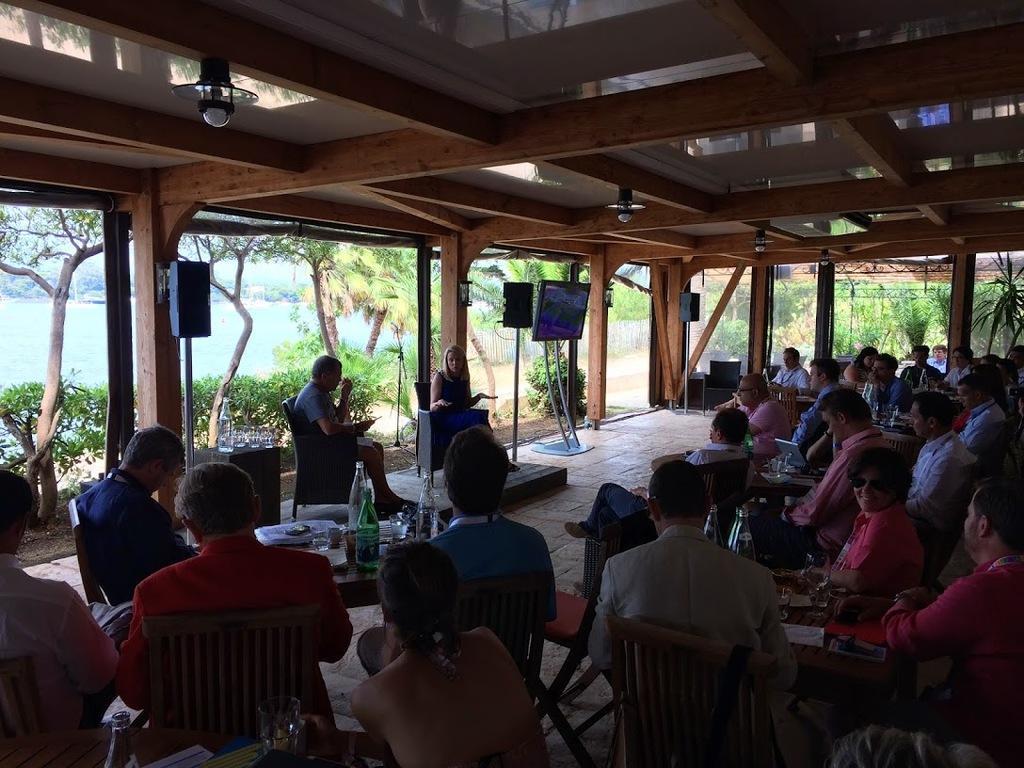Please provide a concise description of this image. There are many people sitting on chairs. And there are many tables. On the table there are bottles and some other items. And there are two persons sitting on the front. And there are two speakers and a TV with a stand. In the background there are trees with water. 